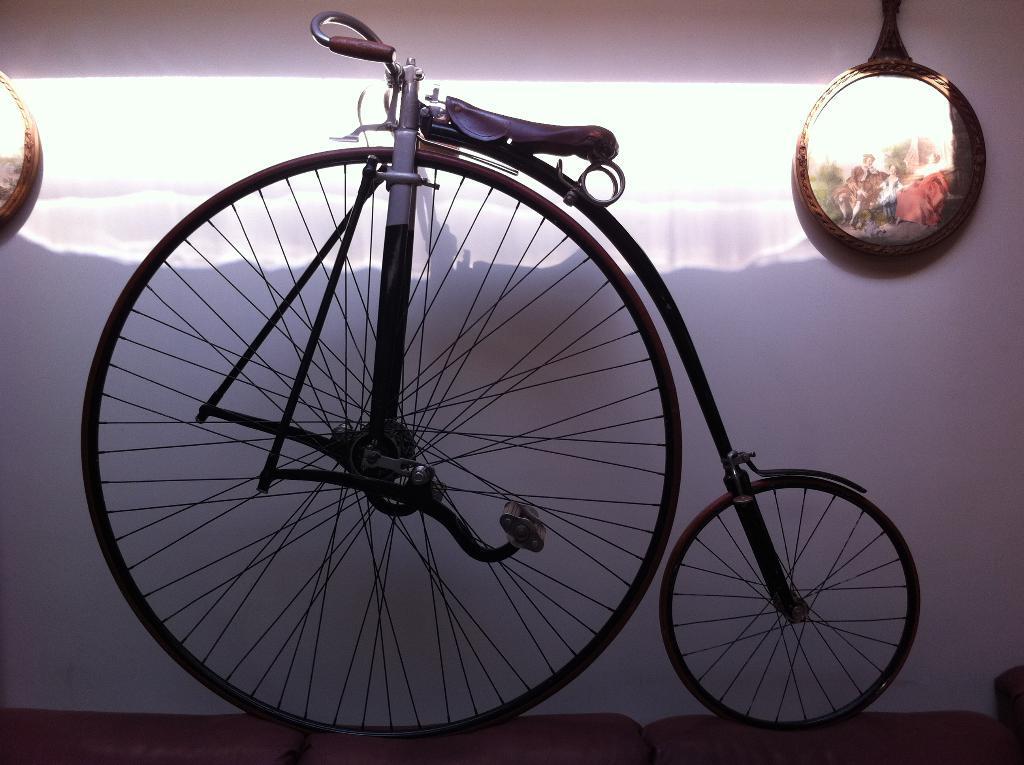Describe this image in one or two sentences. In the center of the image we can see a bicycle. In the background there are frames placed on the wall. At the bottom there is a cloth. 